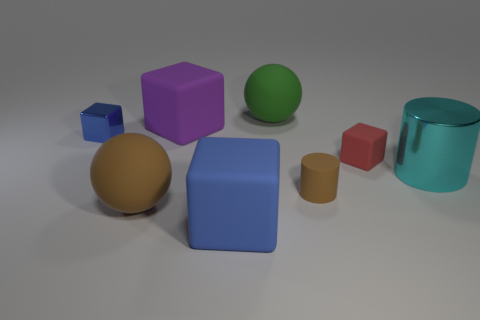Is there a matte cylinder of the same color as the tiny matte cube?
Make the answer very short. No. Is there a large thing made of the same material as the small blue thing?
Offer a very short reply. Yes. What shape is the tiny object that is behind the large metal thing and on the right side of the tiny shiny thing?
Keep it short and to the point. Cube. How many big things are either purple rubber things or green metallic cylinders?
Offer a terse response. 1. What is the material of the big blue object?
Provide a succinct answer. Rubber. What number of other things are the same shape as the large brown thing?
Your response must be concise. 1. The green object has what size?
Ensure brevity in your answer.  Large. There is a rubber object that is in front of the big green matte ball and behind the red matte cube; how big is it?
Keep it short and to the point. Large. What is the shape of the small matte thing in front of the tiny matte cube?
Offer a terse response. Cylinder. Is the material of the large blue block the same as the brown thing that is on the left side of the large blue thing?
Ensure brevity in your answer.  Yes. 